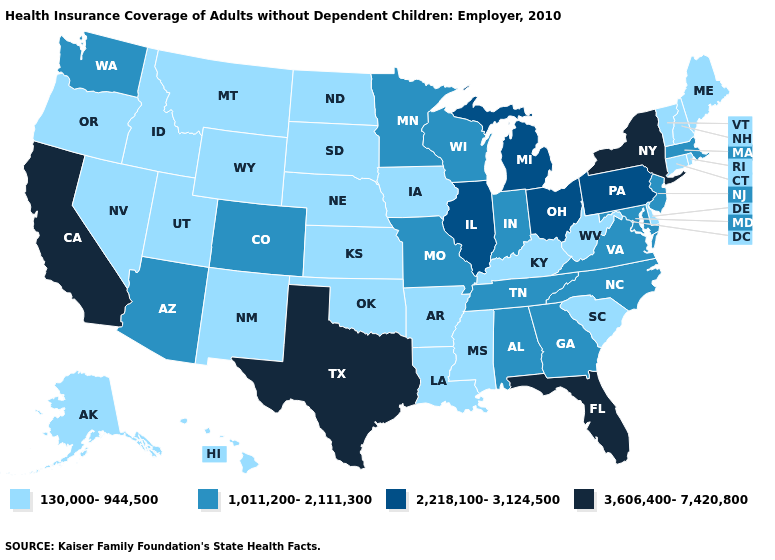What is the value of Virginia?
Give a very brief answer. 1,011,200-2,111,300. Name the states that have a value in the range 2,218,100-3,124,500?
Short answer required. Illinois, Michigan, Ohio, Pennsylvania. Does Missouri have the lowest value in the USA?
Concise answer only. No. Among the states that border Idaho , which have the highest value?
Short answer required. Washington. What is the value of Washington?
Write a very short answer. 1,011,200-2,111,300. Which states have the highest value in the USA?
Give a very brief answer. California, Florida, New York, Texas. Does California have a higher value than Vermont?
Answer briefly. Yes. How many symbols are there in the legend?
Short answer required. 4. Which states have the lowest value in the Northeast?
Short answer required. Connecticut, Maine, New Hampshire, Rhode Island, Vermont. Name the states that have a value in the range 2,218,100-3,124,500?
Be succinct. Illinois, Michigan, Ohio, Pennsylvania. Name the states that have a value in the range 2,218,100-3,124,500?
Be succinct. Illinois, Michigan, Ohio, Pennsylvania. What is the highest value in states that border Virginia?
Short answer required. 1,011,200-2,111,300. What is the value of California?
Concise answer only. 3,606,400-7,420,800. Does Massachusetts have the lowest value in the Northeast?
Give a very brief answer. No. Does Texas have the highest value in the South?
Quick response, please. Yes. 